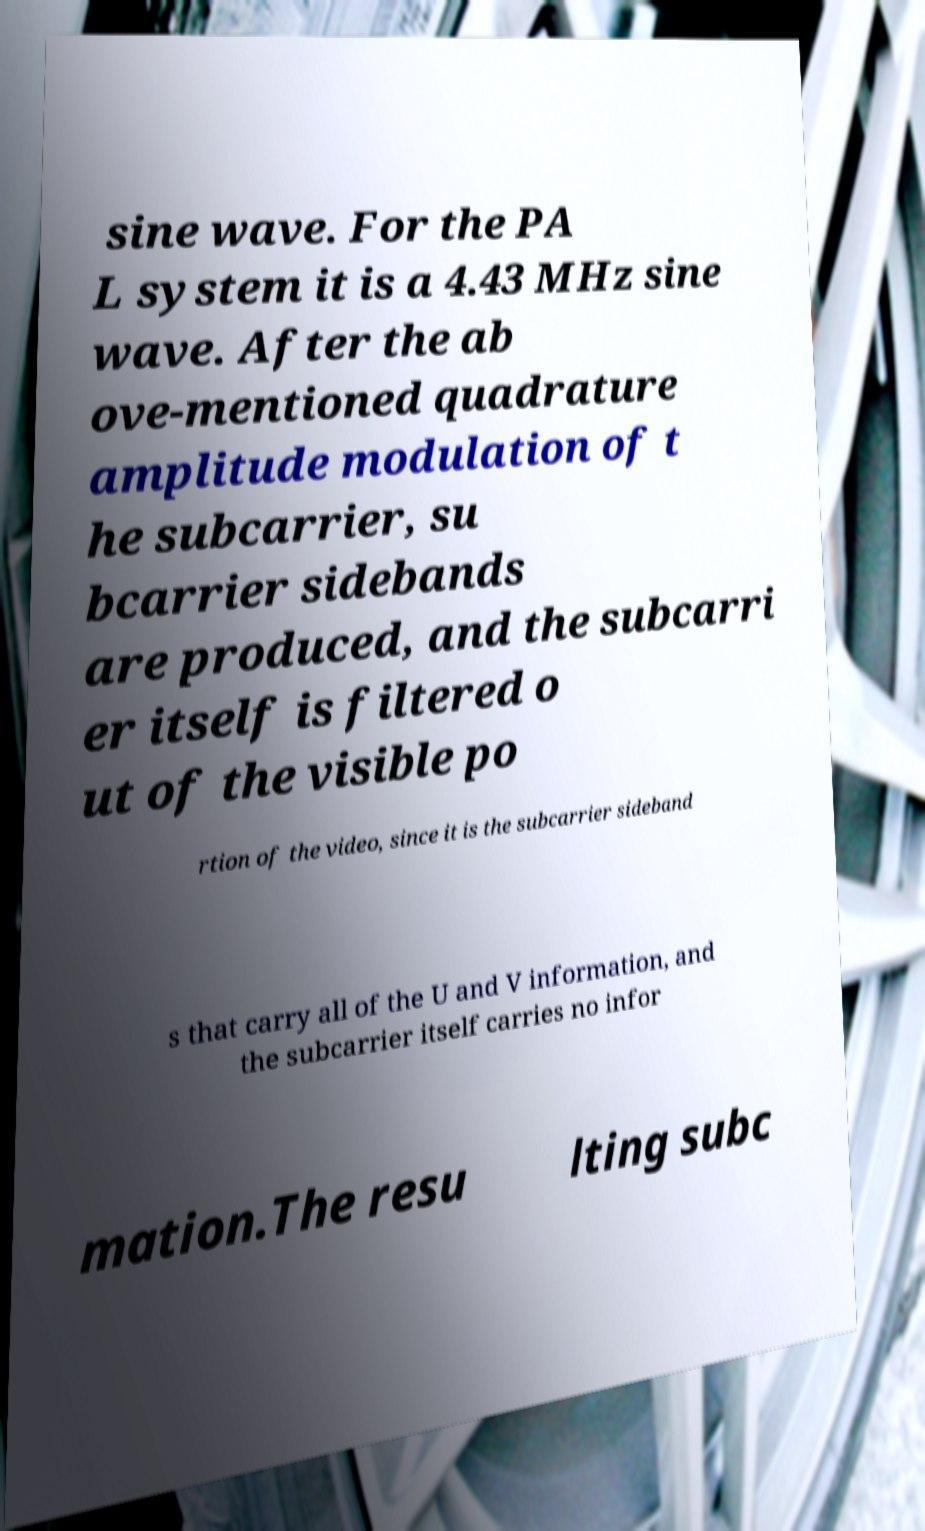Please identify and transcribe the text found in this image. sine wave. For the PA L system it is a 4.43 MHz sine wave. After the ab ove-mentioned quadrature amplitude modulation of t he subcarrier, su bcarrier sidebands are produced, and the subcarri er itself is filtered o ut of the visible po rtion of the video, since it is the subcarrier sideband s that carry all of the U and V information, and the subcarrier itself carries no infor mation.The resu lting subc 